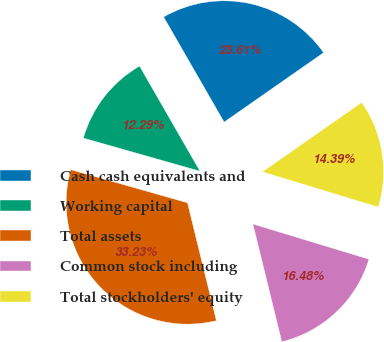Convert chart to OTSL. <chart><loc_0><loc_0><loc_500><loc_500><pie_chart><fcel>Cash cash equivalents and<fcel>Working capital<fcel>Total assets<fcel>Common stock including<fcel>Total stockholders' equity<nl><fcel>23.61%<fcel>12.29%<fcel>33.23%<fcel>16.48%<fcel>14.39%<nl></chart> 